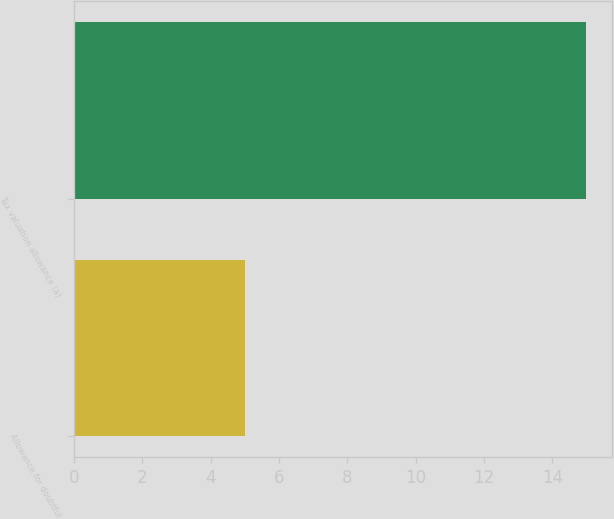<chart> <loc_0><loc_0><loc_500><loc_500><bar_chart><fcel>Allowance for doubtful<fcel>Tax valuation allowance (a)<nl><fcel>5<fcel>15<nl></chart> 